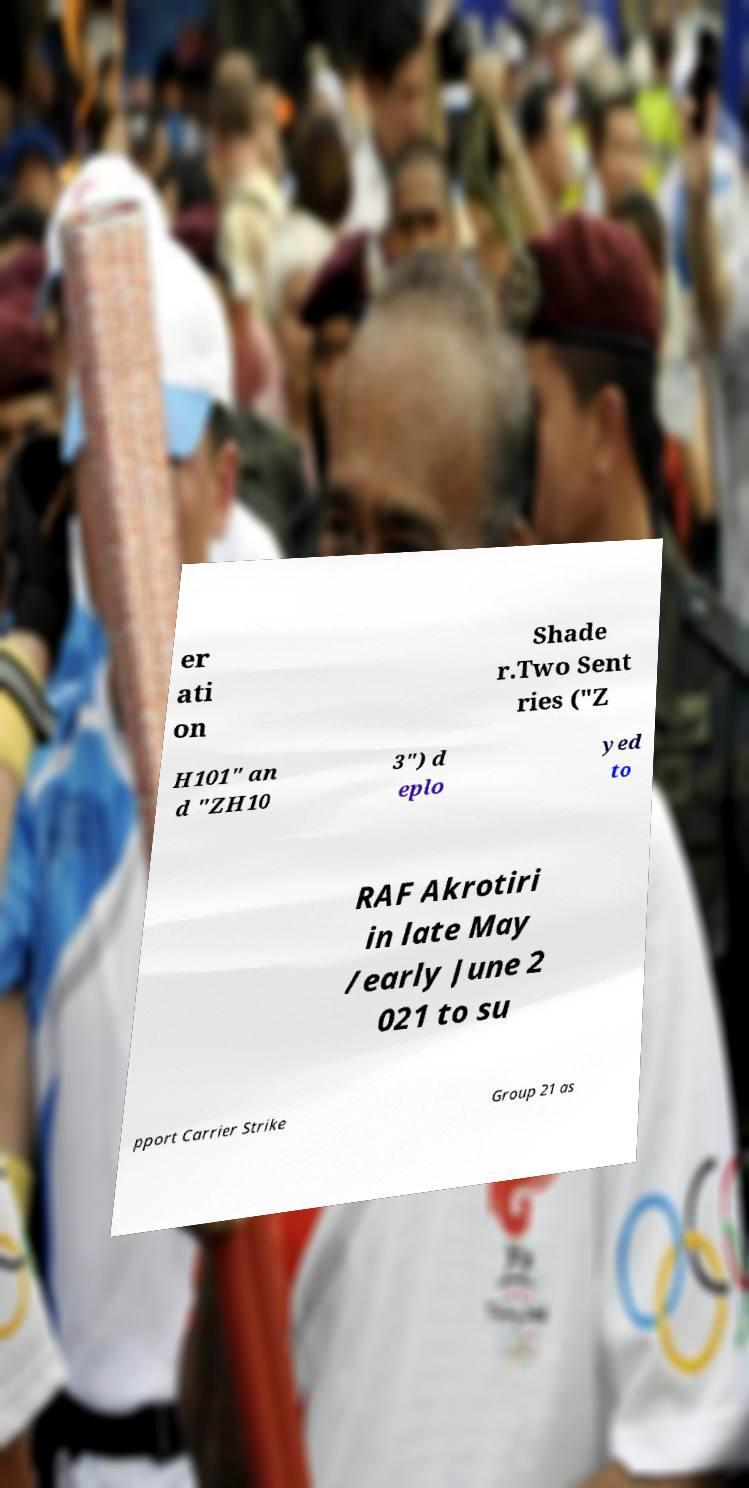What messages or text are displayed in this image? I need them in a readable, typed format. er ati on Shade r.Two Sent ries ("Z H101" an d "ZH10 3") d eplo yed to RAF Akrotiri in late May /early June 2 021 to su pport Carrier Strike Group 21 as 